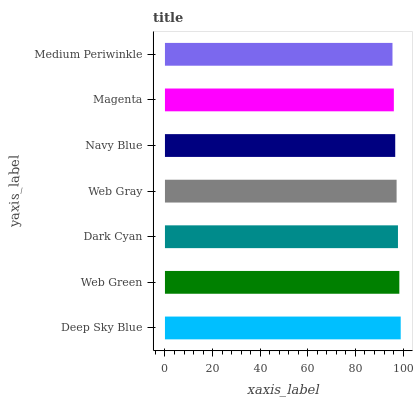Is Medium Periwinkle the minimum?
Answer yes or no. Yes. Is Deep Sky Blue the maximum?
Answer yes or no. Yes. Is Web Green the minimum?
Answer yes or no. No. Is Web Green the maximum?
Answer yes or no. No. Is Deep Sky Blue greater than Web Green?
Answer yes or no. Yes. Is Web Green less than Deep Sky Blue?
Answer yes or no. Yes. Is Web Green greater than Deep Sky Blue?
Answer yes or no. No. Is Deep Sky Blue less than Web Green?
Answer yes or no. No. Is Web Gray the high median?
Answer yes or no. Yes. Is Web Gray the low median?
Answer yes or no. Yes. Is Magenta the high median?
Answer yes or no. No. Is Navy Blue the low median?
Answer yes or no. No. 